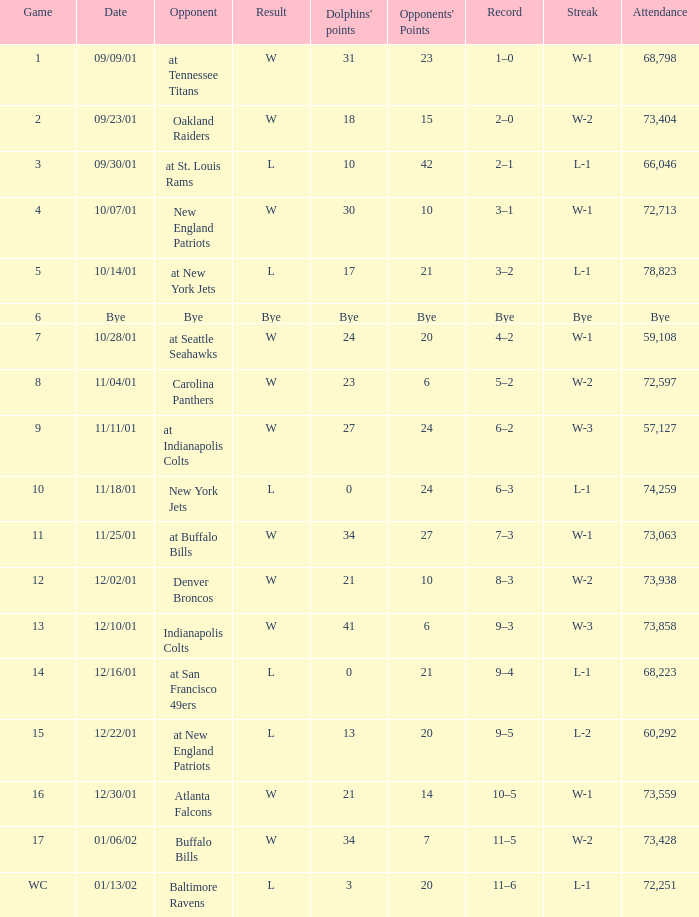What is the streak for game 16 when the Dolphins had 21 points? W-1. 